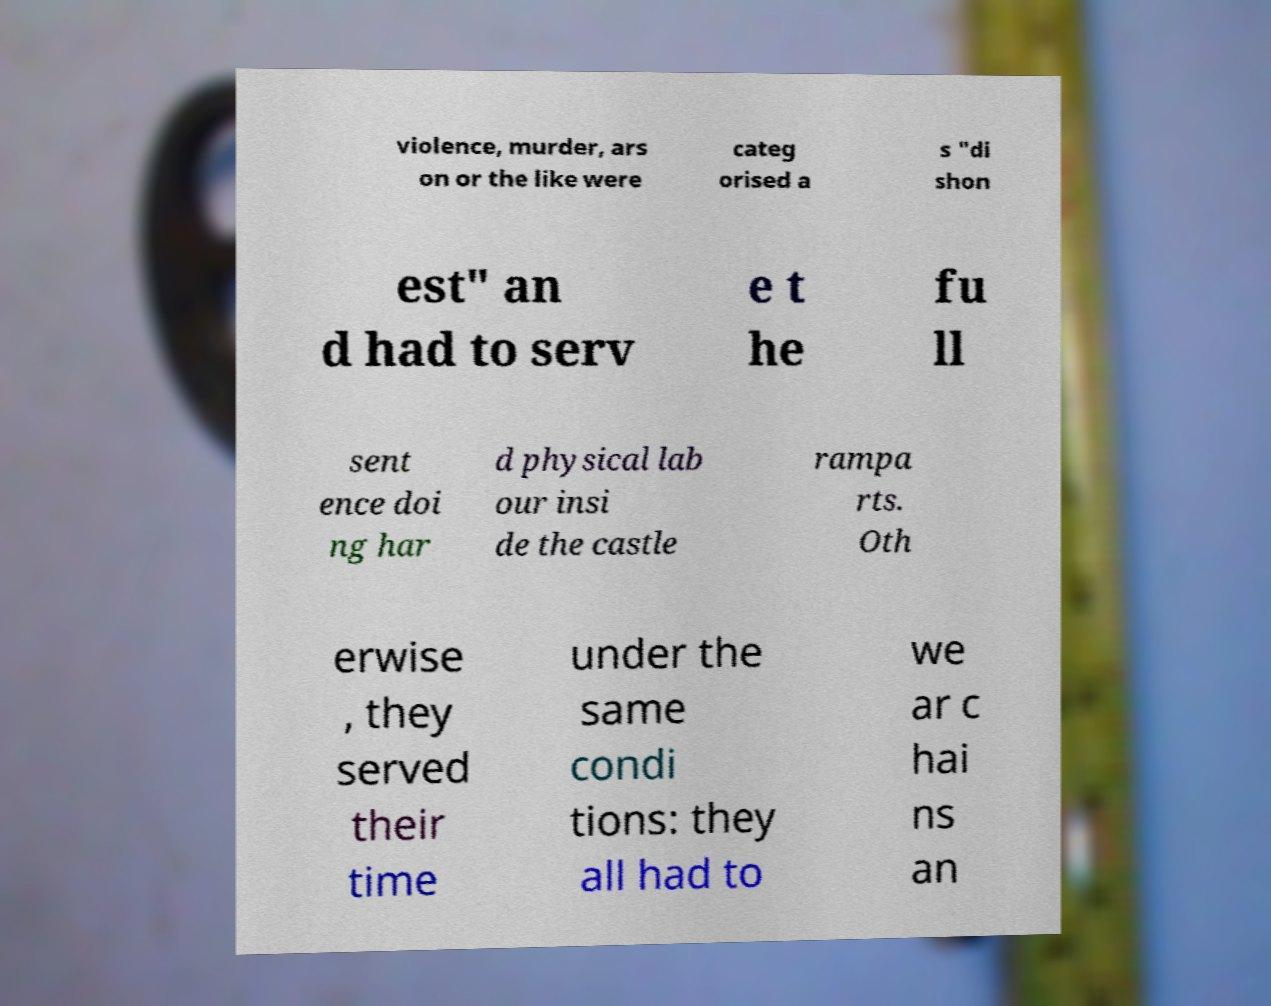Please identify and transcribe the text found in this image. violence, murder, ars on or the like were categ orised a s "di shon est" an d had to serv e t he fu ll sent ence doi ng har d physical lab our insi de the castle rampa rts. Oth erwise , they served their time under the same condi tions: they all had to we ar c hai ns an 